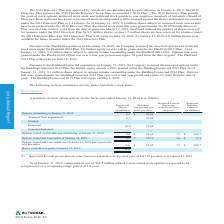According to Autodesk's financial document, At January 31, 2019, how many shares were available for future issuance? Based on the financial document, the answer is 8.1 million. Also, What is the offering period for ESPP awards? Based on the financial document, the answer is The offering period for ESPP awards consists of four, six-month exercise periods within a 24-month offering period.. Also, What was the average price of issued shares in the fiscal year ended 2018? Based on the financial document, the answer is $39.03. Also, can you calculate: What was the average compensation expense over the period from 2017 to 2019? To answer this question, I need to perform calculations using the financial data. The calculation is: (27.2+25.7+25.9)/3, which equals 26.27 (in millions). The key data points involved are: 25.7, 25.9, 27.2. Also, can you calculate: What is the change in the weighted average grant date fair value of awards granted under the ESPP from 2017 to 2018? Based on the calculation: 32.41-19.2, the result is 13.21. The key data points involved are: 19.2, 32.41. Also, can you calculate: What was the average compensation expense over the period from 2017 to 2019? To answer this question, I need to perform calculations using the financial data. The calculation is: (27.2+25.7+25.9)/3 , which equals 26.27. The key data points involved are: 25.7, 25.9, 27.2. 